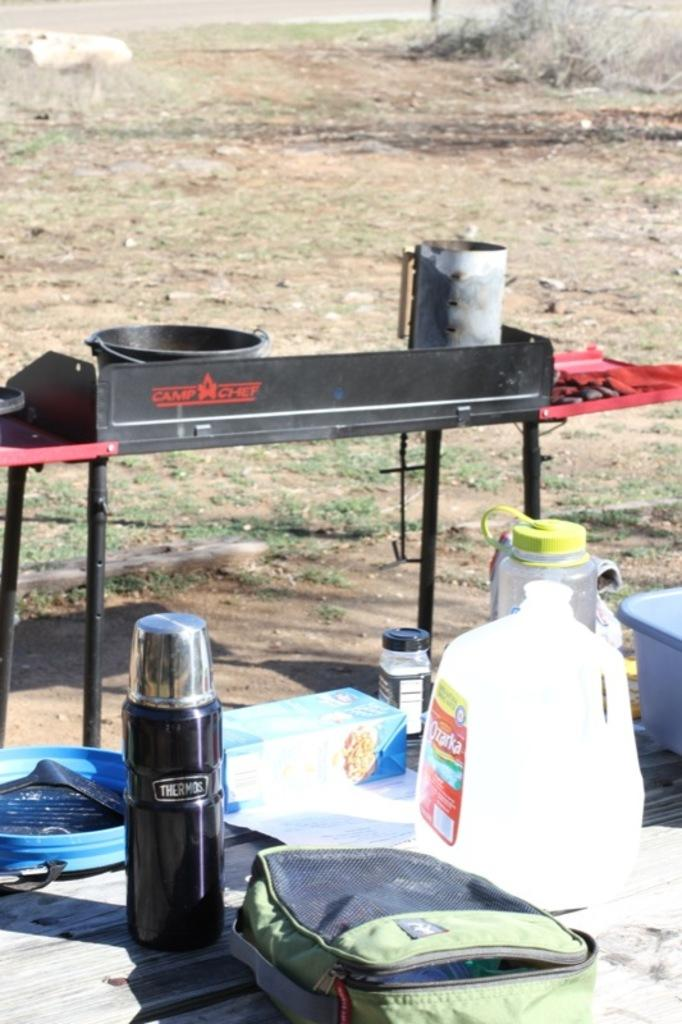What type of furniture is present in the image? There is a table in the image. What items can be seen on the table? There is a bag, a can, a flask, a box, a bottle, and a basket on the table. Are there any other tables visible in the image? Yes, there is another table in the image, and there is a table vessel on it. What can be seen in the background of the image? The ground is visible in the background of the image. Can you see any bread on the table in the image? There is no bread present on the table in the image. Is there a person sitting at the table in the image? There is no person visible in the image. 